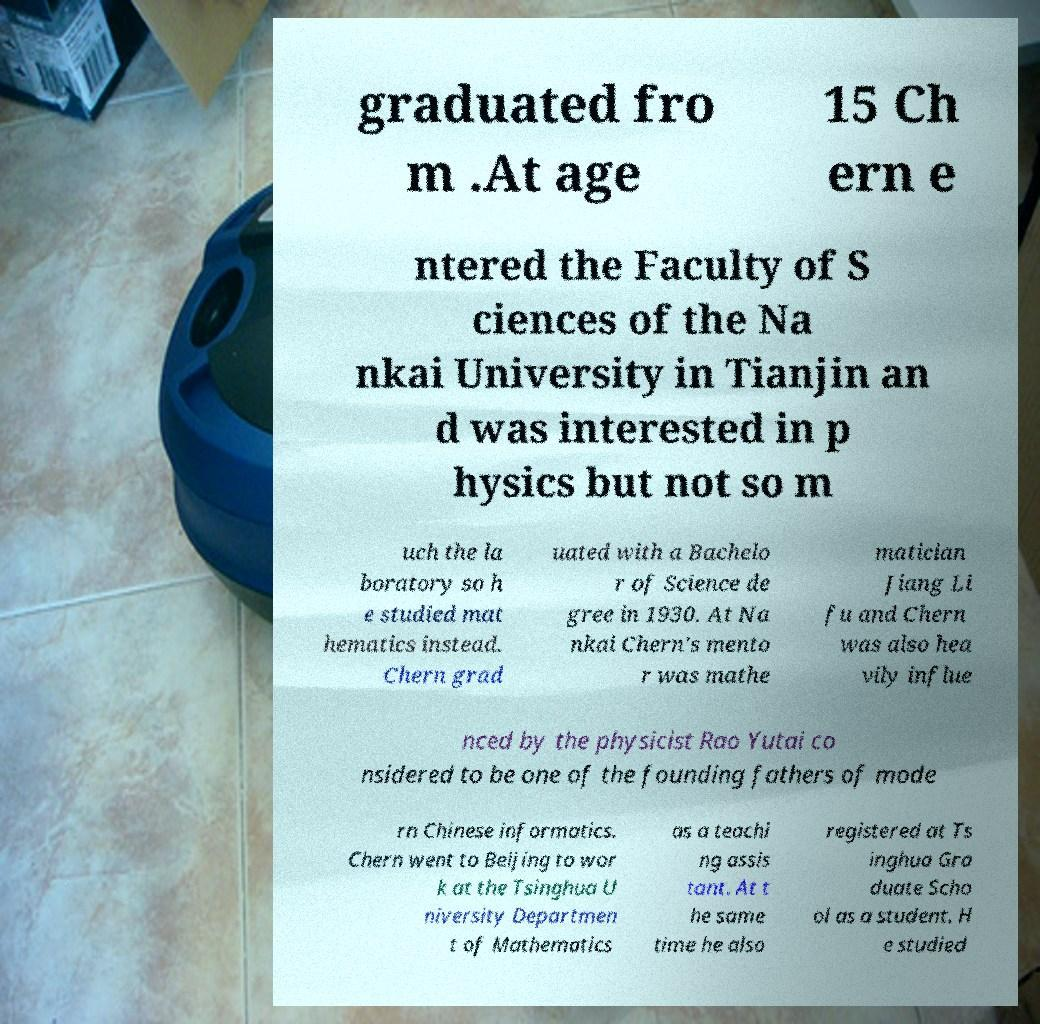What messages or text are displayed in this image? I need them in a readable, typed format. graduated fro m .At age 15 Ch ern e ntered the Faculty of S ciences of the Na nkai University in Tianjin an d was interested in p hysics but not so m uch the la boratory so h e studied mat hematics instead. Chern grad uated with a Bachelo r of Science de gree in 1930. At Na nkai Chern's mento r was mathe matician Jiang Li fu and Chern was also hea vily influe nced by the physicist Rao Yutai co nsidered to be one of the founding fathers of mode rn Chinese informatics. Chern went to Beijing to wor k at the Tsinghua U niversity Departmen t of Mathematics as a teachi ng assis tant. At t he same time he also registered at Ts inghua Gra duate Scho ol as a student. H e studied 